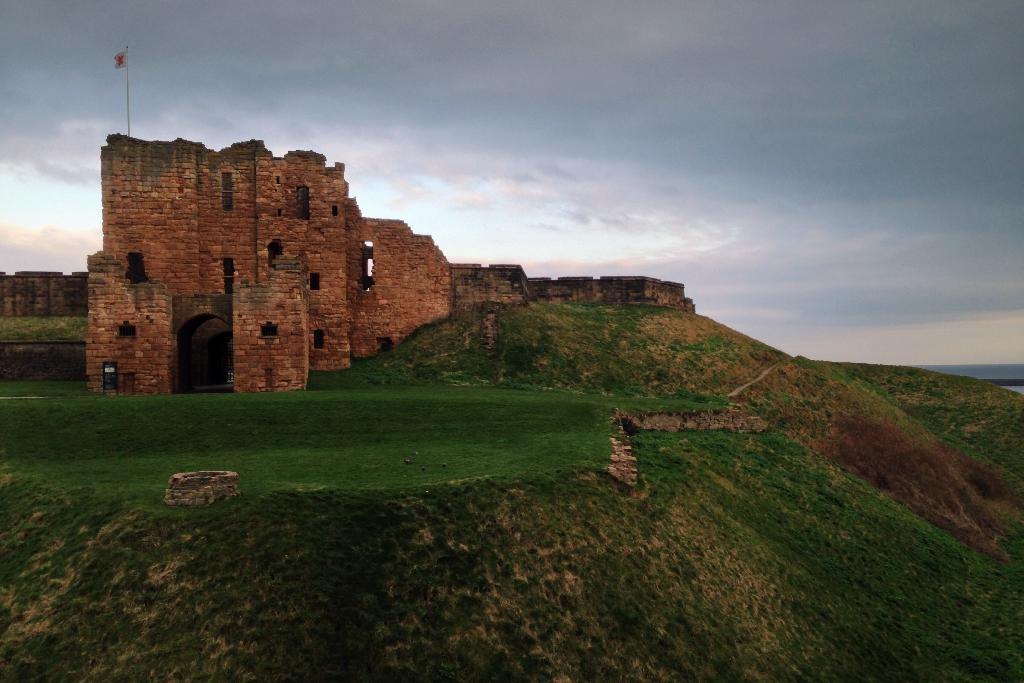What structure is the main subject of the image? There is a fort in the image. Where is the fort located? The fort is on a hill. What type of vegetation is present on the hill? There is grass on the hill. What can be seen at the top of the fort? There is a flag on a pole at the top of the fort. What is visible at the top of the image? The sky is visible at the top of the image. How many people are represented by the flag on the pole at the top of the fort? The image does not provide information about the number of people represented by the flag; it only shows the flag itself. 